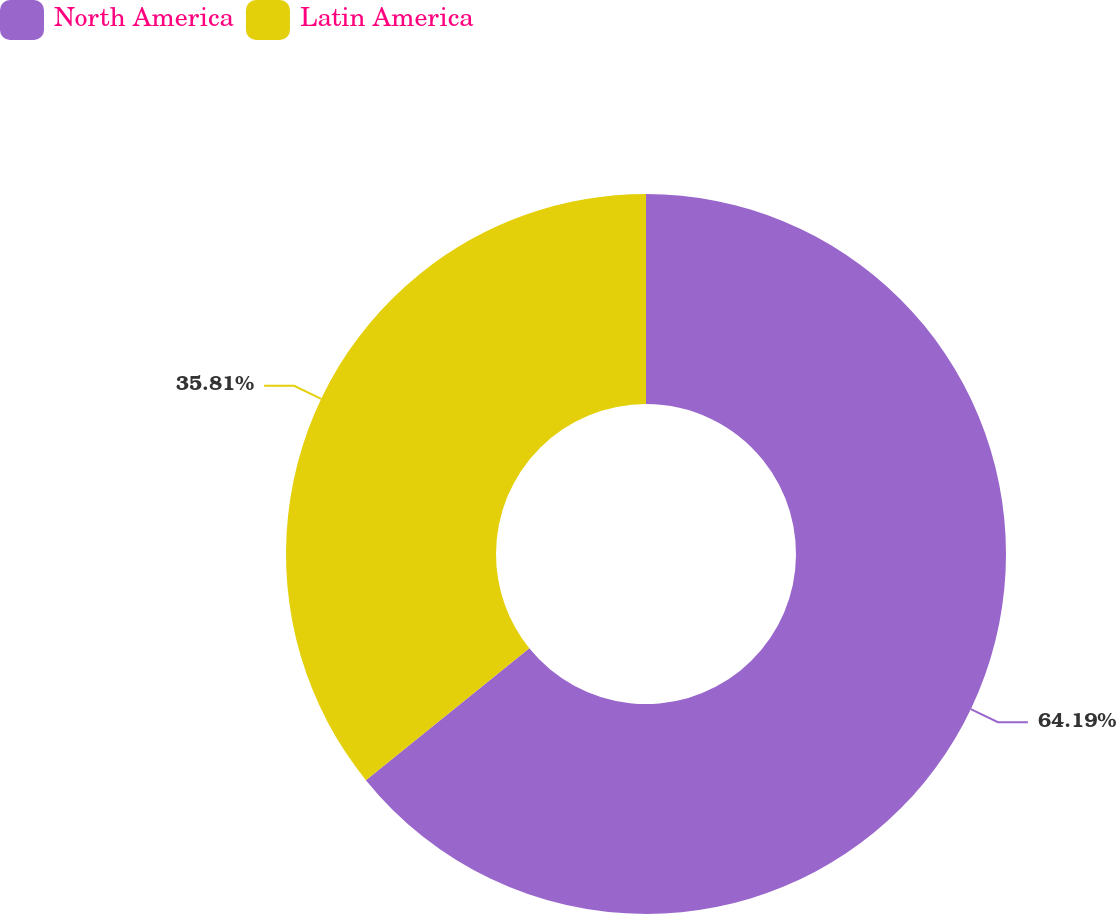<chart> <loc_0><loc_0><loc_500><loc_500><pie_chart><fcel>North America<fcel>Latin America<nl><fcel>64.19%<fcel>35.81%<nl></chart> 